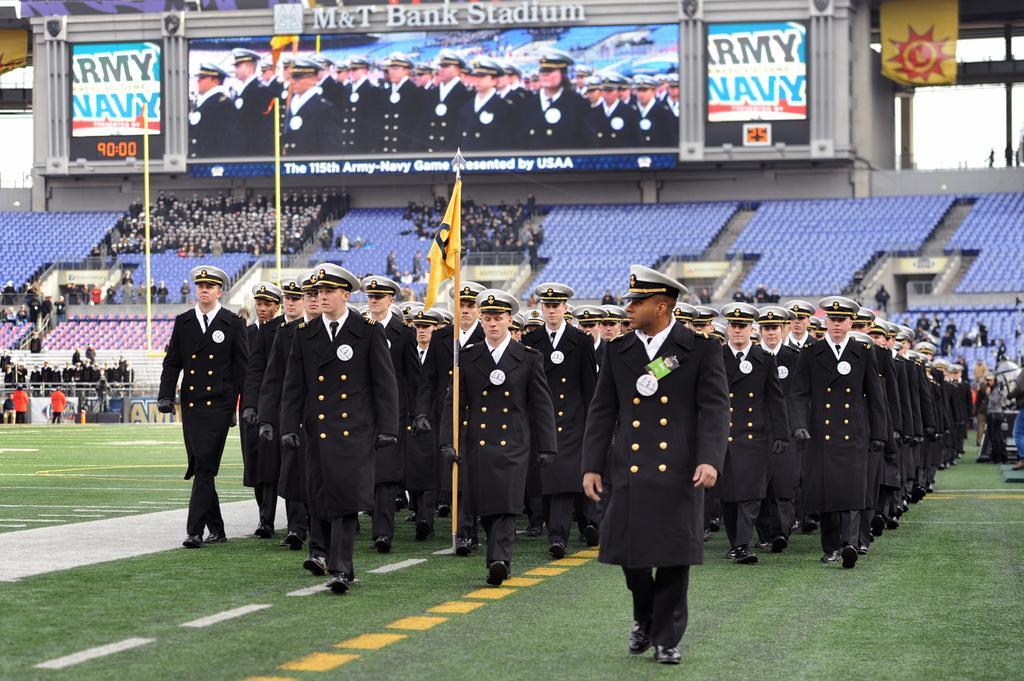Please provide a concise description of this image. In this image few persons are wearing black color uniform are walking on the grass land. They are wearing caps. A person is holding a stick which is having a flag to it. Right side there are few persons standing on the grass land. Few persons are sitting on the chair which are on the stairs. Left side few persons are standing on the grassland and few persons are standing behind the fence. Top of image there is a screen attached to the wall. Beside there is a flag hangs from the roof. 